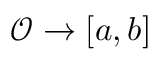<formula> <loc_0><loc_0><loc_500><loc_500>\mathcal { O } \rightarrow [ a , b ]</formula> 